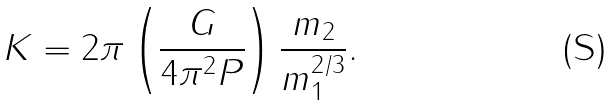Convert formula to latex. <formula><loc_0><loc_0><loc_500><loc_500>K = 2 \pi \left ( \frac { G } { 4 \pi ^ { 2 } P } \right ) \frac { m _ { 2 } } { m _ { 1 } ^ { 2 / 3 } } .</formula> 